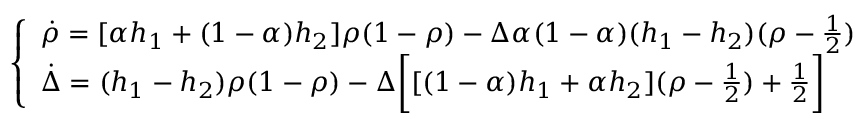Convert formula to latex. <formula><loc_0><loc_0><loc_500><loc_500>\left \{ \begin{array} { l l } { \dot { \rho } = [ \alpha h _ { 1 } + ( 1 - \alpha ) h _ { 2 } ] \rho ( 1 - \rho ) - \Delta \alpha ( 1 - \alpha ) ( h _ { 1 } - h _ { 2 } ) ( \rho - \frac { 1 } { 2 } ) } \\ { \dot { \Delta } = ( h _ { 1 } - h _ { 2 } ) \rho ( 1 - \rho ) - \Delta \left [ [ ( 1 - \alpha ) h _ { 1 } + \alpha h _ { 2 } ] ( \rho - \frac { 1 } { 2 } ) + \frac { 1 } { 2 } \right ] } \end{array}</formula> 